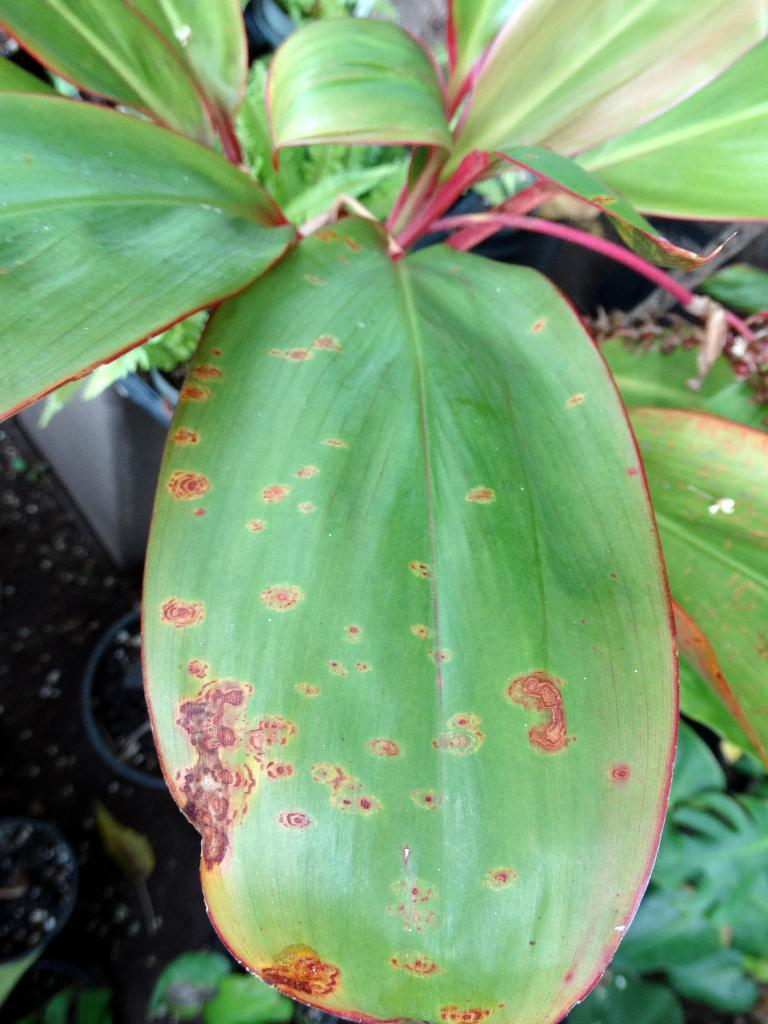What type of vegetation can be seen in the image? There are leaves in the image. What type of surface is visible in the image? There is land visible in the image. Where is the pot located in the image? The pot is on the left side of the image. How many chickens are visible in the image? There are no chickens present in the image. What sound does the whistle make in the image? There is no whistle present in the image. 